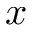Convert formula to latex. <formula><loc_0><loc_0><loc_500><loc_500>x</formula> 